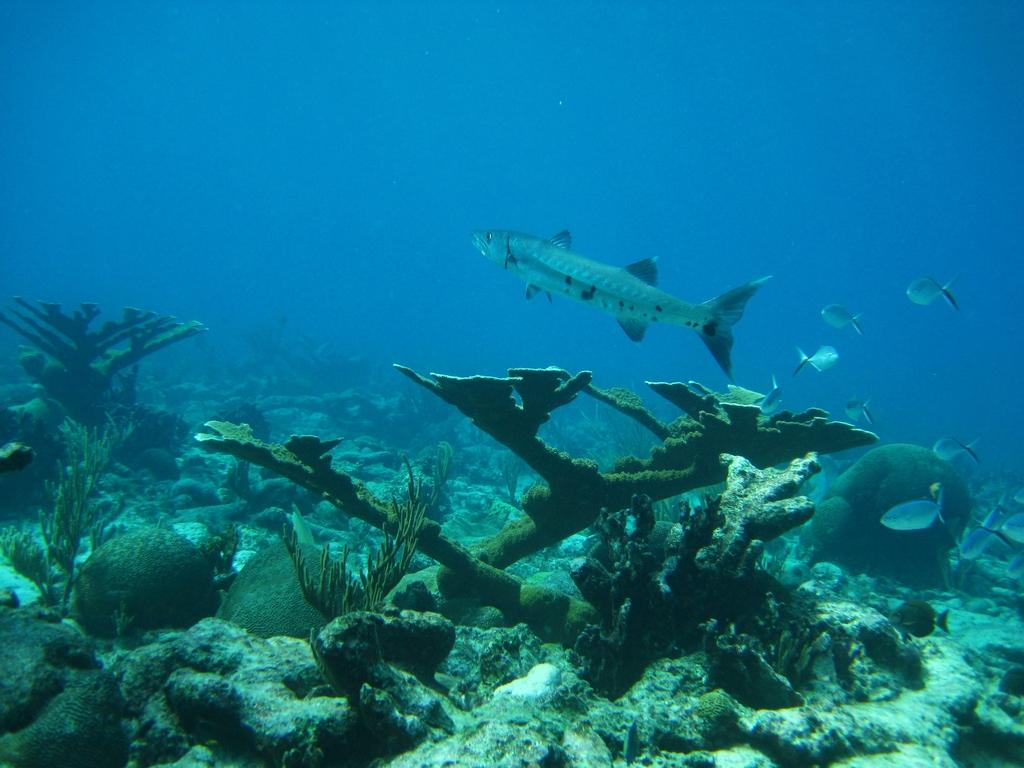What type of animals can be seen in the image? There are fish in the water. What other elements can be seen in the image besides the fish? There are plants and rocks in the image. What type of mist can be seen surrounding the goose in the image? There is no goose present in the image, and therefore no mist surrounding it. What type of drug is being used by the fish in the image? There is no drug present in the image, and the fish are not depicted as using any substances. 